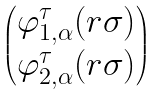<formula> <loc_0><loc_0><loc_500><loc_500>\begin{pmatrix} \varphi ^ { \tau } _ { 1 , \alpha } ( r \sigma ) \\ \varphi ^ { \tau } _ { 2 , \alpha } ( r \sigma ) \end{pmatrix}</formula> 